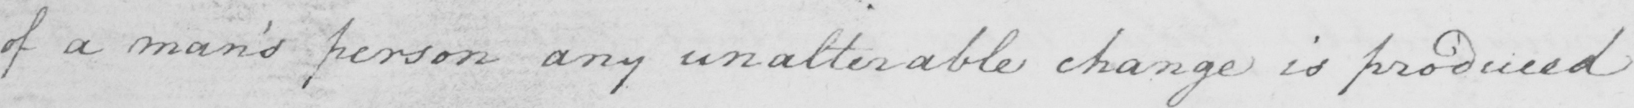Can you read and transcribe this handwriting? of a man's person any unalterable change is produced 